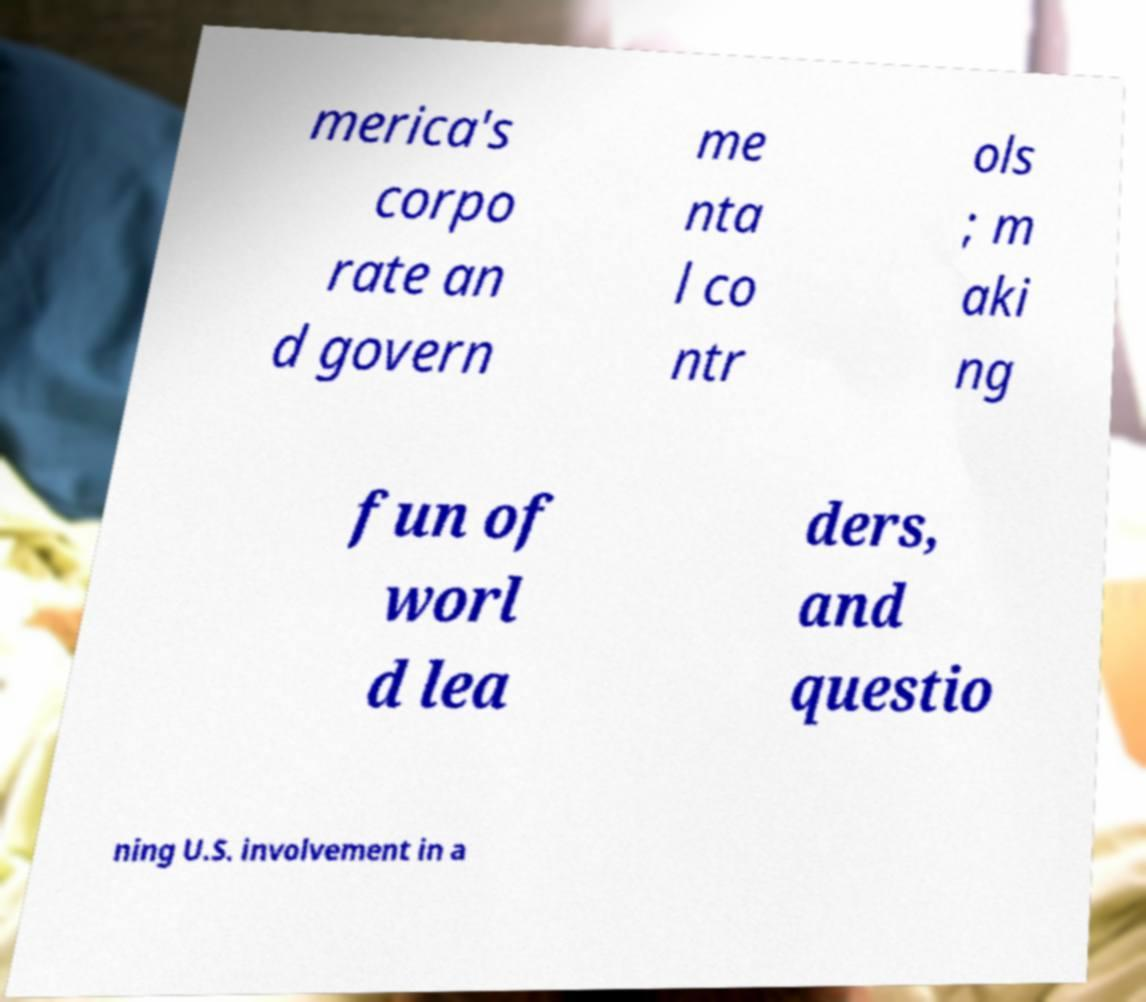What messages or text are displayed in this image? I need them in a readable, typed format. merica's corpo rate an d govern me nta l co ntr ols ; m aki ng fun of worl d lea ders, and questio ning U.S. involvement in a 